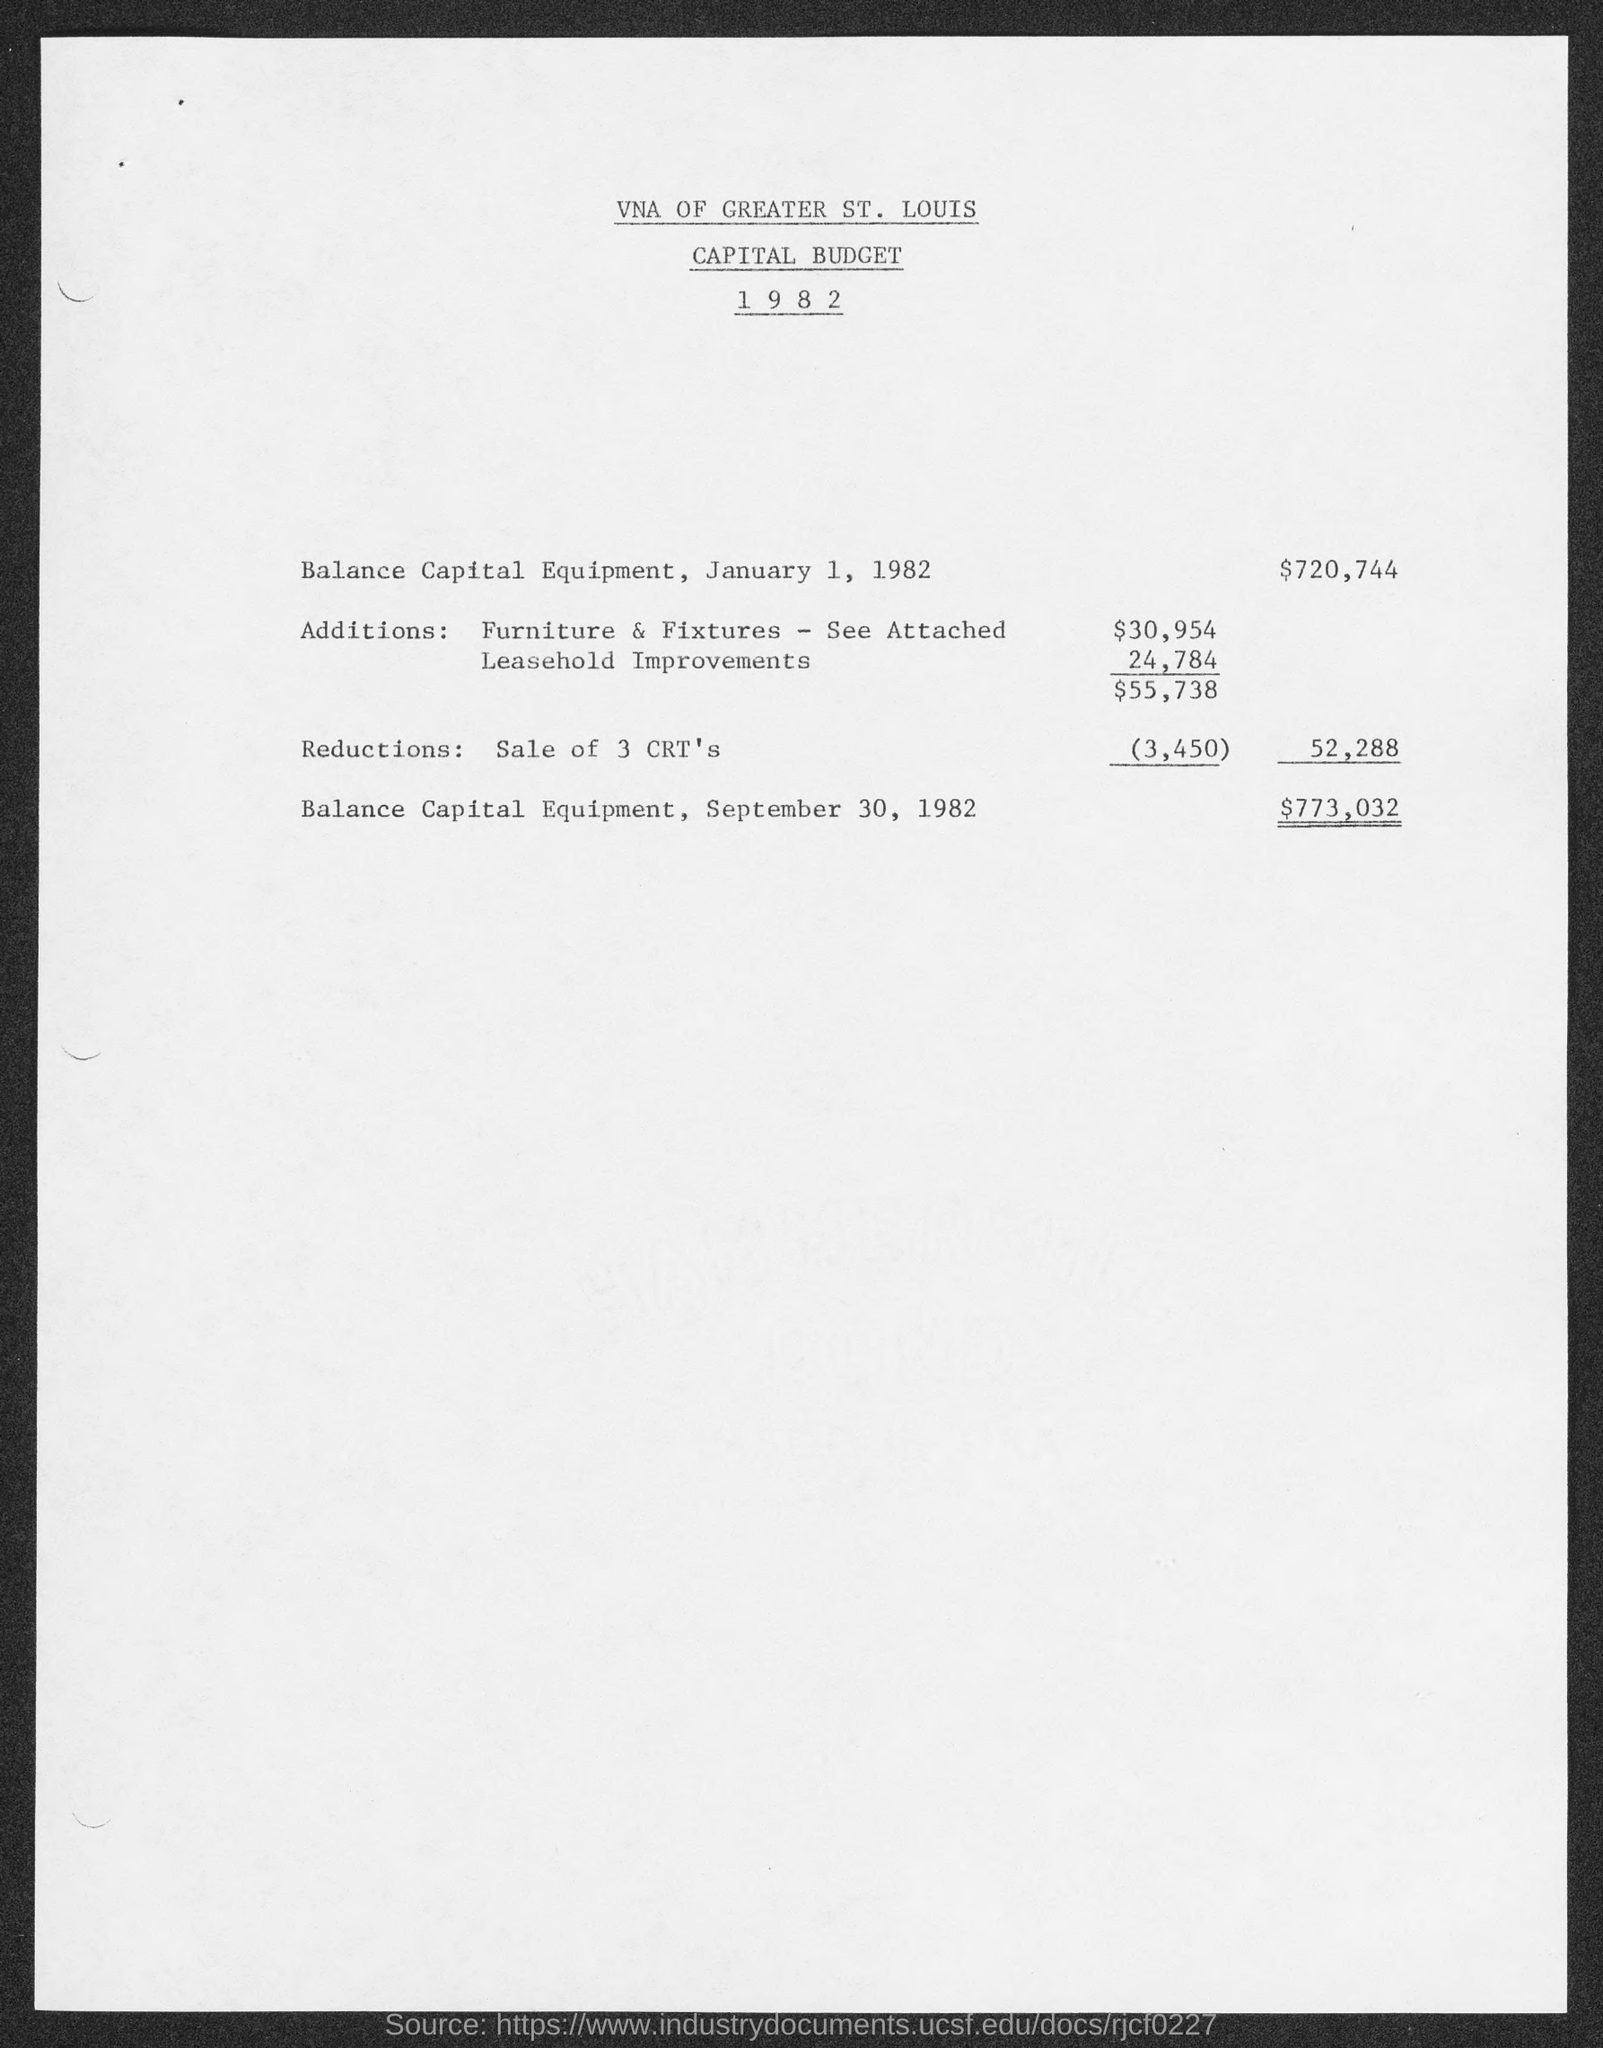What is the balance capital equipment , january 1, 1982?
Your response must be concise. $720,744. What is the balance capital equipment , september 30, 1982?
Provide a succinct answer. $773,032. 